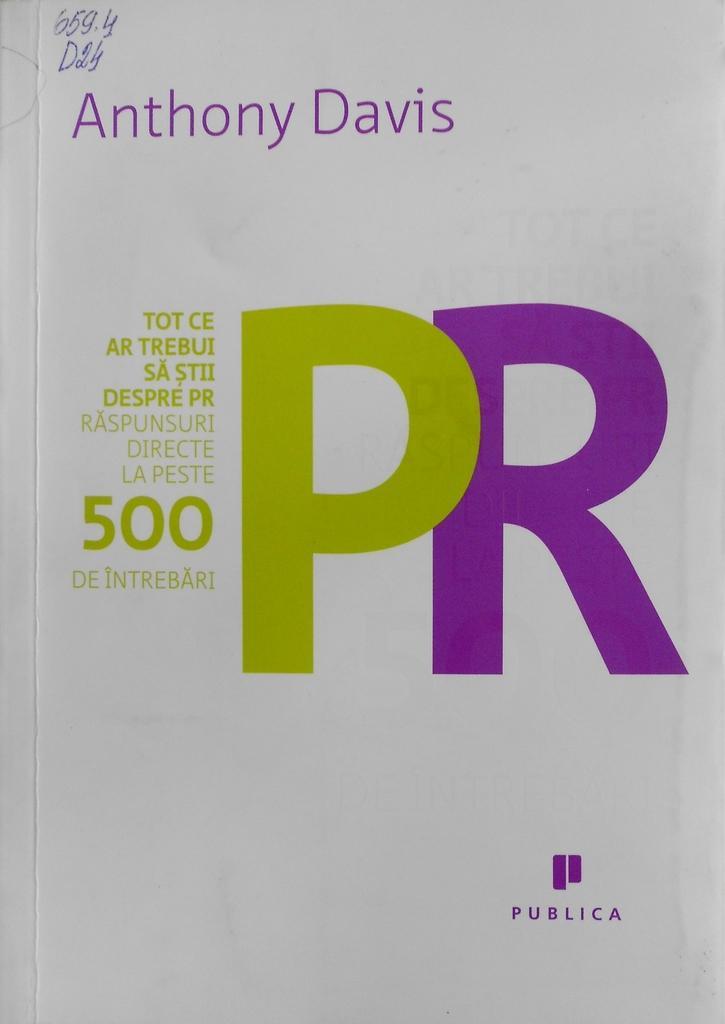In one or two sentences, can you explain what this image depicts? In this image, we can see a white color poster, on that poster ANTHONY DAVIS is printed. 